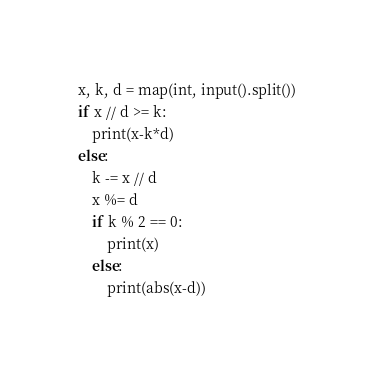Convert code to text. <code><loc_0><loc_0><loc_500><loc_500><_Python_>x, k, d = map(int, input().split())
if x // d >= k:
    print(x-k*d)
else:
    k -= x // d
    x %= d
    if k % 2 == 0:
        print(x)
    else:
        print(abs(x-d))
</code> 